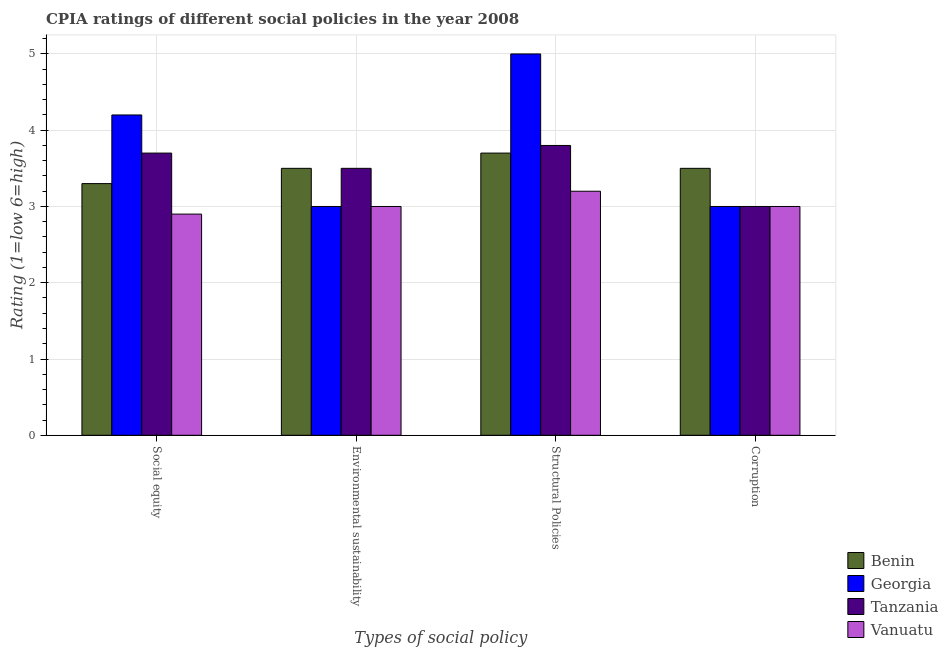How many bars are there on the 3rd tick from the right?
Your answer should be very brief. 4. What is the label of the 1st group of bars from the left?
Your answer should be compact. Social equity. Across all countries, what is the minimum cpia rating of environmental sustainability?
Offer a terse response. 3. In which country was the cpia rating of structural policies maximum?
Offer a very short reply. Georgia. In which country was the cpia rating of social equity minimum?
Offer a very short reply. Vanuatu. What is the difference between the cpia rating of social equity in Tanzania and the cpia rating of corruption in Vanuatu?
Offer a very short reply. 0.7. What is the difference between the cpia rating of corruption and cpia rating of structural policies in Tanzania?
Give a very brief answer. -0.8. What is the ratio of the cpia rating of structural policies in Vanuatu to that in Tanzania?
Provide a succinct answer. 0.84. Is the difference between the cpia rating of social equity in Georgia and Tanzania greater than the difference between the cpia rating of environmental sustainability in Georgia and Tanzania?
Offer a very short reply. Yes. What is the difference between the highest and the lowest cpia rating of structural policies?
Ensure brevity in your answer.  1.8. What does the 1st bar from the left in Corruption represents?
Your response must be concise. Benin. What does the 2nd bar from the right in Corruption represents?
Keep it short and to the point. Tanzania. What is the difference between two consecutive major ticks on the Y-axis?
Make the answer very short. 1. Are the values on the major ticks of Y-axis written in scientific E-notation?
Offer a terse response. No. Does the graph contain any zero values?
Offer a terse response. No. Where does the legend appear in the graph?
Offer a very short reply. Bottom right. How many legend labels are there?
Keep it short and to the point. 4. How are the legend labels stacked?
Provide a succinct answer. Vertical. What is the title of the graph?
Give a very brief answer. CPIA ratings of different social policies in the year 2008. What is the label or title of the X-axis?
Offer a very short reply. Types of social policy. What is the Rating (1=low 6=high) of Vanuatu in Social equity?
Your response must be concise. 2.9. What is the Rating (1=low 6=high) of Benin in Environmental sustainability?
Keep it short and to the point. 3.5. What is the Rating (1=low 6=high) of Georgia in Environmental sustainability?
Offer a terse response. 3. What is the Rating (1=low 6=high) in Benin in Structural Policies?
Give a very brief answer. 3.7. What is the Rating (1=low 6=high) in Tanzania in Structural Policies?
Offer a terse response. 3.8. What is the Rating (1=low 6=high) of Georgia in Corruption?
Give a very brief answer. 3. What is the Rating (1=low 6=high) of Vanuatu in Corruption?
Provide a short and direct response. 3. Across all Types of social policy, what is the maximum Rating (1=low 6=high) in Benin?
Your response must be concise. 3.7. Across all Types of social policy, what is the maximum Rating (1=low 6=high) of Georgia?
Give a very brief answer. 5. Across all Types of social policy, what is the minimum Rating (1=low 6=high) of Georgia?
Make the answer very short. 3. Across all Types of social policy, what is the minimum Rating (1=low 6=high) in Vanuatu?
Your response must be concise. 2.9. What is the total Rating (1=low 6=high) of Benin in the graph?
Make the answer very short. 14. What is the difference between the Rating (1=low 6=high) in Georgia in Social equity and that in Environmental sustainability?
Make the answer very short. 1.2. What is the difference between the Rating (1=low 6=high) of Tanzania in Social equity and that in Environmental sustainability?
Offer a terse response. 0.2. What is the difference between the Rating (1=low 6=high) of Georgia in Social equity and that in Structural Policies?
Ensure brevity in your answer.  -0.8. What is the difference between the Rating (1=low 6=high) in Vanuatu in Social equity and that in Structural Policies?
Ensure brevity in your answer.  -0.3. What is the difference between the Rating (1=low 6=high) in Vanuatu in Social equity and that in Corruption?
Keep it short and to the point. -0.1. What is the difference between the Rating (1=low 6=high) in Tanzania in Environmental sustainability and that in Structural Policies?
Offer a very short reply. -0.3. What is the difference between the Rating (1=low 6=high) in Tanzania in Environmental sustainability and that in Corruption?
Provide a short and direct response. 0.5. What is the difference between the Rating (1=low 6=high) in Vanuatu in Environmental sustainability and that in Corruption?
Your answer should be compact. 0. What is the difference between the Rating (1=low 6=high) in Benin in Structural Policies and that in Corruption?
Your response must be concise. 0.2. What is the difference between the Rating (1=low 6=high) in Benin in Social equity and the Rating (1=low 6=high) in Tanzania in Environmental sustainability?
Give a very brief answer. -0.2. What is the difference between the Rating (1=low 6=high) in Georgia in Social equity and the Rating (1=low 6=high) in Vanuatu in Environmental sustainability?
Provide a short and direct response. 1.2. What is the difference between the Rating (1=low 6=high) of Tanzania in Social equity and the Rating (1=low 6=high) of Vanuatu in Environmental sustainability?
Offer a terse response. 0.7. What is the difference between the Rating (1=low 6=high) of Benin in Social equity and the Rating (1=low 6=high) of Tanzania in Structural Policies?
Offer a terse response. -0.5. What is the difference between the Rating (1=low 6=high) of Tanzania in Social equity and the Rating (1=low 6=high) of Vanuatu in Structural Policies?
Your answer should be compact. 0.5. What is the difference between the Rating (1=low 6=high) in Benin in Social equity and the Rating (1=low 6=high) in Georgia in Corruption?
Your answer should be compact. 0.3. What is the difference between the Rating (1=low 6=high) in Benin in Social equity and the Rating (1=low 6=high) in Vanuatu in Corruption?
Your response must be concise. 0.3. What is the difference between the Rating (1=low 6=high) in Georgia in Social equity and the Rating (1=low 6=high) in Tanzania in Corruption?
Provide a short and direct response. 1.2. What is the difference between the Rating (1=low 6=high) in Benin in Environmental sustainability and the Rating (1=low 6=high) in Georgia in Corruption?
Provide a succinct answer. 0.5. What is the difference between the Rating (1=low 6=high) in Benin in Environmental sustainability and the Rating (1=low 6=high) in Tanzania in Corruption?
Ensure brevity in your answer.  0.5. What is the difference between the Rating (1=low 6=high) of Tanzania in Environmental sustainability and the Rating (1=low 6=high) of Vanuatu in Corruption?
Keep it short and to the point. 0.5. What is the difference between the Rating (1=low 6=high) in Benin in Structural Policies and the Rating (1=low 6=high) in Vanuatu in Corruption?
Provide a short and direct response. 0.7. What is the difference between the Rating (1=low 6=high) in Georgia in Structural Policies and the Rating (1=low 6=high) in Vanuatu in Corruption?
Provide a short and direct response. 2. What is the difference between the Rating (1=low 6=high) in Tanzania in Structural Policies and the Rating (1=low 6=high) in Vanuatu in Corruption?
Offer a terse response. 0.8. What is the average Rating (1=low 6=high) in Tanzania per Types of social policy?
Ensure brevity in your answer.  3.5. What is the average Rating (1=low 6=high) in Vanuatu per Types of social policy?
Your answer should be very brief. 3.02. What is the difference between the Rating (1=low 6=high) in Benin and Rating (1=low 6=high) in Georgia in Social equity?
Ensure brevity in your answer.  -0.9. What is the difference between the Rating (1=low 6=high) of Benin and Rating (1=low 6=high) of Vanuatu in Social equity?
Offer a terse response. 0.4. What is the difference between the Rating (1=low 6=high) in Georgia and Rating (1=low 6=high) in Vanuatu in Social equity?
Make the answer very short. 1.3. What is the difference between the Rating (1=low 6=high) of Benin and Rating (1=low 6=high) of Tanzania in Environmental sustainability?
Your answer should be very brief. 0. What is the difference between the Rating (1=low 6=high) in Benin and Rating (1=low 6=high) in Vanuatu in Environmental sustainability?
Offer a terse response. 0.5. What is the difference between the Rating (1=low 6=high) of Georgia and Rating (1=low 6=high) of Tanzania in Environmental sustainability?
Keep it short and to the point. -0.5. What is the difference between the Rating (1=low 6=high) in Georgia and Rating (1=low 6=high) in Vanuatu in Environmental sustainability?
Provide a short and direct response. 0. What is the difference between the Rating (1=low 6=high) of Tanzania and Rating (1=low 6=high) of Vanuatu in Environmental sustainability?
Your response must be concise. 0.5. What is the difference between the Rating (1=low 6=high) of Benin and Rating (1=low 6=high) of Georgia in Structural Policies?
Give a very brief answer. -1.3. What is the difference between the Rating (1=low 6=high) of Benin and Rating (1=low 6=high) of Vanuatu in Structural Policies?
Give a very brief answer. 0.5. What is the difference between the Rating (1=low 6=high) in Georgia and Rating (1=low 6=high) in Vanuatu in Structural Policies?
Offer a very short reply. 1.8. What is the difference between the Rating (1=low 6=high) in Benin and Rating (1=low 6=high) in Tanzania in Corruption?
Offer a very short reply. 0.5. What is the difference between the Rating (1=low 6=high) of Tanzania and Rating (1=low 6=high) of Vanuatu in Corruption?
Offer a very short reply. 0. What is the ratio of the Rating (1=low 6=high) in Benin in Social equity to that in Environmental sustainability?
Provide a succinct answer. 0.94. What is the ratio of the Rating (1=low 6=high) in Tanzania in Social equity to that in Environmental sustainability?
Provide a short and direct response. 1.06. What is the ratio of the Rating (1=low 6=high) of Vanuatu in Social equity to that in Environmental sustainability?
Offer a very short reply. 0.97. What is the ratio of the Rating (1=low 6=high) in Benin in Social equity to that in Structural Policies?
Provide a short and direct response. 0.89. What is the ratio of the Rating (1=low 6=high) in Georgia in Social equity to that in Structural Policies?
Keep it short and to the point. 0.84. What is the ratio of the Rating (1=low 6=high) in Tanzania in Social equity to that in Structural Policies?
Offer a very short reply. 0.97. What is the ratio of the Rating (1=low 6=high) of Vanuatu in Social equity to that in Structural Policies?
Provide a succinct answer. 0.91. What is the ratio of the Rating (1=low 6=high) in Benin in Social equity to that in Corruption?
Give a very brief answer. 0.94. What is the ratio of the Rating (1=low 6=high) in Georgia in Social equity to that in Corruption?
Provide a succinct answer. 1.4. What is the ratio of the Rating (1=low 6=high) in Tanzania in Social equity to that in Corruption?
Offer a terse response. 1.23. What is the ratio of the Rating (1=low 6=high) in Vanuatu in Social equity to that in Corruption?
Offer a very short reply. 0.97. What is the ratio of the Rating (1=low 6=high) in Benin in Environmental sustainability to that in Structural Policies?
Make the answer very short. 0.95. What is the ratio of the Rating (1=low 6=high) in Tanzania in Environmental sustainability to that in Structural Policies?
Offer a terse response. 0.92. What is the ratio of the Rating (1=low 6=high) of Vanuatu in Environmental sustainability to that in Structural Policies?
Your answer should be compact. 0.94. What is the ratio of the Rating (1=low 6=high) of Benin in Environmental sustainability to that in Corruption?
Make the answer very short. 1. What is the ratio of the Rating (1=low 6=high) of Vanuatu in Environmental sustainability to that in Corruption?
Keep it short and to the point. 1. What is the ratio of the Rating (1=low 6=high) of Benin in Structural Policies to that in Corruption?
Provide a short and direct response. 1.06. What is the ratio of the Rating (1=low 6=high) in Tanzania in Structural Policies to that in Corruption?
Offer a terse response. 1.27. What is the ratio of the Rating (1=low 6=high) in Vanuatu in Structural Policies to that in Corruption?
Offer a terse response. 1.07. What is the difference between the highest and the second highest Rating (1=low 6=high) in Benin?
Your answer should be very brief. 0.2. What is the difference between the highest and the second highest Rating (1=low 6=high) of Tanzania?
Keep it short and to the point. 0.1. What is the difference between the highest and the second highest Rating (1=low 6=high) in Vanuatu?
Provide a succinct answer. 0.2. What is the difference between the highest and the lowest Rating (1=low 6=high) of Benin?
Your answer should be very brief. 0.4. What is the difference between the highest and the lowest Rating (1=low 6=high) of Georgia?
Provide a succinct answer. 2. What is the difference between the highest and the lowest Rating (1=low 6=high) of Tanzania?
Offer a terse response. 0.8. 